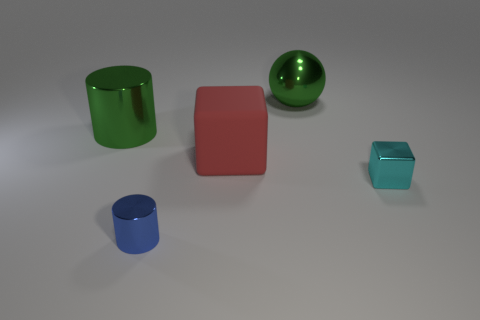Add 4 big metal balls. How many objects exist? 9 Subtract all balls. How many objects are left? 4 Subtract 0 yellow cylinders. How many objects are left? 5 Subtract all large red cubes. Subtract all big red blocks. How many objects are left? 3 Add 1 big red objects. How many big red objects are left? 2 Add 1 large purple shiny cubes. How many large purple shiny cubes exist? 1 